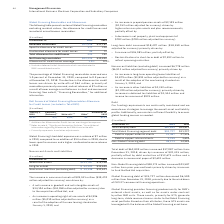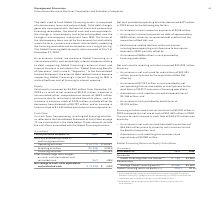According to International Business Machines's financial document, What caused the decrease in the total debt? driven by issuances of $32,415 million; partially offset by debt maturities of $12,673 million and a decrease in commercial paper of $2,691 million.. The document states: "increased $17,087 million from December 31, 2018, driven by issuances of $32,415 million; partially offset by debt maturities of $12,673 million and a..." Also, What was the increase in the Non-Global Financing debt from 2018? According to the financial document, $23,587 million. The relevant text states: "Global Financing debt of $38,173 million increased $23,587 million from prior year-end levels primarily driven by issuances to fund the Red Hat acquisition...." Also, What was the increase in the Global Financing debt from 2018? According to the financial document, $6,500 million. The relevant text states: "Global Financing debt of $24,727 million decreased $6,500 million from December 31, 2018, primarily due to the wind down of OEM IT commercial financing operations...." Also, can you calculate: What was the increase / (decrease) in the total company debt from 2018 to 2019? Based on the calculation: 62,899 - 45,812, the result is 17087 (in millions). This is based on the information: "Total company debt $62,899 $45,812 Total company debt $62,899 $45,812..." The key data points involved are: 45,812, 62,899. Also, can you calculate: What was the average Debt to support external clients? To answer this question, I need to perform calculations using the financial data. The calculation is: (21,487 + 27,536) / 2, which equals 24511.5 (in millions). This is based on the information: "Debt to support external clients 21,487 27,536 Debt to support external clients 21,487 27,536..." The key data points involved are: 21,487, 27,536. Also, can you calculate: What is the percentage increase / (decrease) in the Non-Global Financing debt from 2018 to 2019? To answer this question, I need to perform calculations using the financial data. The calculation is: 38,173 / 14,585 - 1, which equals 161.73 (percentage). This is based on the information: "Non-Global Financing debt 38,173 14,585 Non-Global Financing debt 38,173 14,585..." The key data points involved are: 14,585, 38,173. 